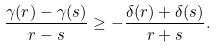<formula> <loc_0><loc_0><loc_500><loc_500>\frac { \gamma ( r ) - \gamma ( s ) } { r - s } \geq - \frac { \delta ( r ) + \delta ( s ) } { r + s } .</formula> 